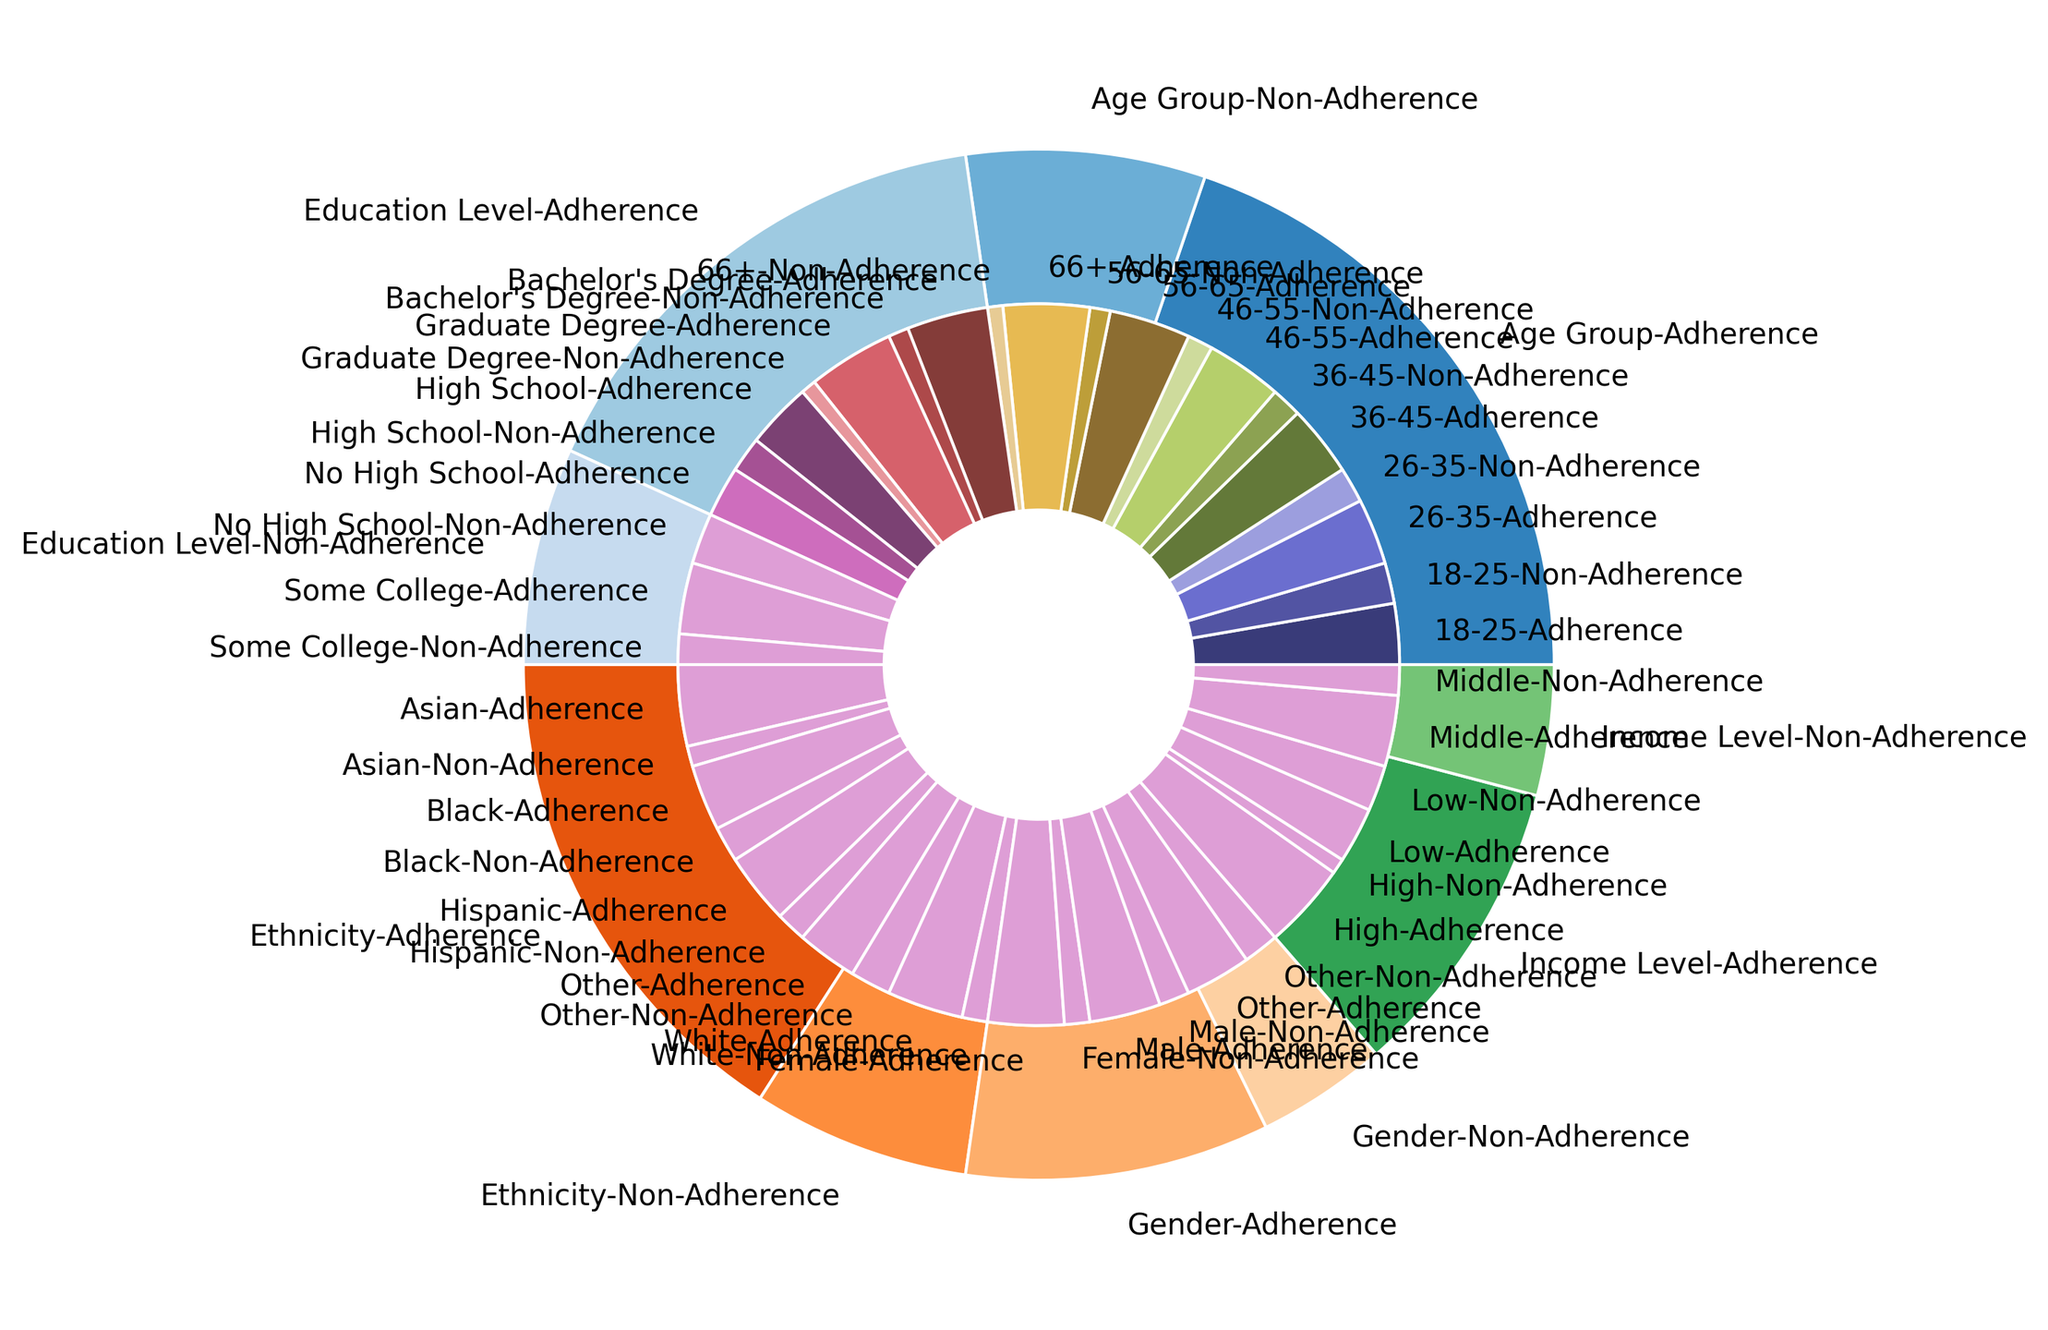Which age group has the highest medication adherence rate? By examining the pie chart and focusing on the "Age Group" section, the innermost donut slice labeled "66+-Adherence" is the largest among the adherence sections, indicating that individuals aged 66+ have the highest adherence rate.
Answer: 66+ Which demographic demonstrates the largest disparity between adherence and non-adherence rates? Observing the pie chart's demographic categories, the "Education Level-No High School" segment has the most balanced sections of Adherence and Non-Adherence, appearing closest to an even split. To identify the largest disparity, we compare the segments, and the "Education Level-No High School" has the smallest gap, thus indicating other demographics have larger disparities.
Answer: Education Level-No High School How does medication adherence vary between males and females? Comparing the respective sections within the "Gender" category, the adherence rate for females (75%) is higher compared to males (70%).
Answer: Females have higher adherence than males Which ethnicity group has the lowest medication adherence rate? By looking at the "Ethnicity" segment, the innermost donut slice labeled "Ethnicity-Other-Adherence" has the smallest size among the adherence sections, indicating that the "Other" ethnicity group has the lowest adherence rate.
Answer: Other What is the combined adherence rate for patients aged 26-35 and 36-45? From the "Age Group" section of the chart, the adherence rates for the 26-35 and 36-45 age groups are 65% and 70%, respectively. Adding these, we get 65 + 70 = 135.
Answer: 135 Which education level shows the highest non-adherence rate? In the "Education Level" section, the non-adherence rate is highest for "No High School" as it visually takes up the largest non-adherence section within this category.
Answer: No High School Which demographic group has the closest adherence rate between "Adherence" and "Non-Adherence"? Among all demographic categories, "Education Level-No High School" appears nearly balanced in both adherence and non-adherence slices, indicating the closest rates.
Answer: Education Level-No High School How does the adherence rate for the Low Income Level compare to Middle Income Level? In the "Income Level" category, the low-income level shows a 55% adherence rate, whereas the middle-income level indicates a 70% adherence rate—showing middle-income has higher adherence.
Answer: Middle income level has higher adherence than low income level What percentage of the highest education level adhere to their medication? Within the "Education Level" section, the adherence rate for "Graduate Degree" (the highest education level represented) is 85%.
Answer: 85% 